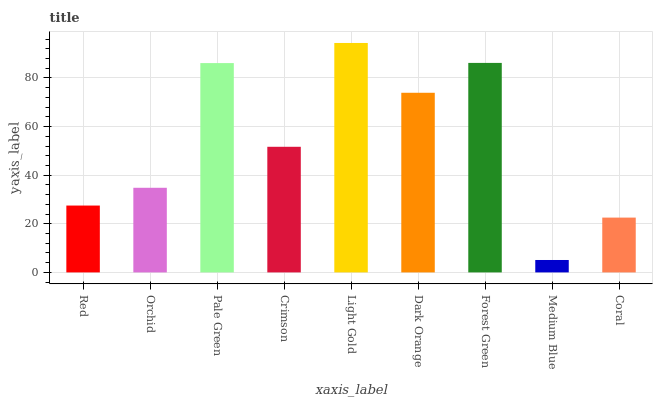Is Medium Blue the minimum?
Answer yes or no. Yes. Is Light Gold the maximum?
Answer yes or no. Yes. Is Orchid the minimum?
Answer yes or no. No. Is Orchid the maximum?
Answer yes or no. No. Is Orchid greater than Red?
Answer yes or no. Yes. Is Red less than Orchid?
Answer yes or no. Yes. Is Red greater than Orchid?
Answer yes or no. No. Is Orchid less than Red?
Answer yes or no. No. Is Crimson the high median?
Answer yes or no. Yes. Is Crimson the low median?
Answer yes or no. Yes. Is Light Gold the high median?
Answer yes or no. No. Is Dark Orange the low median?
Answer yes or no. No. 